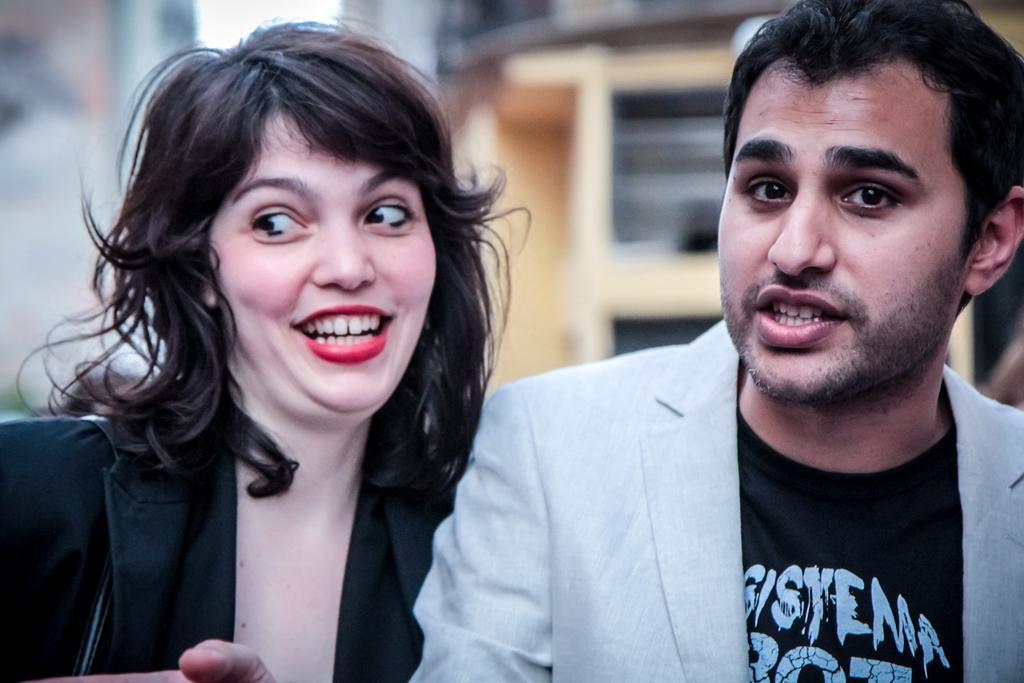Can you describe this image briefly? In this image there is a woman wearing a black jacket. Beside there is a person wearing suit. Behind them there are few buildings. 